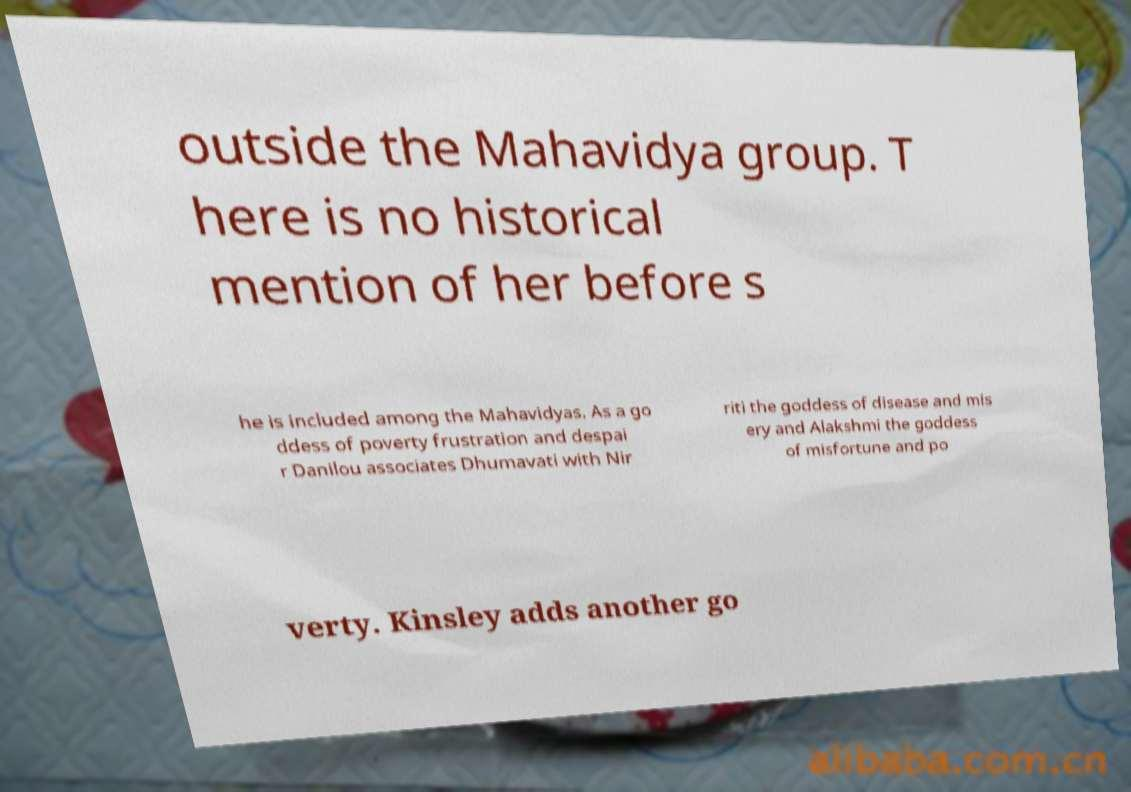I need the written content from this picture converted into text. Can you do that? outside the Mahavidya group. T here is no historical mention of her before s he is included among the Mahavidyas. As a go ddess of poverty frustration and despai r Danilou associates Dhumavati with Nir riti the goddess of disease and mis ery and Alakshmi the goddess of misfortune and po verty. Kinsley adds another go 